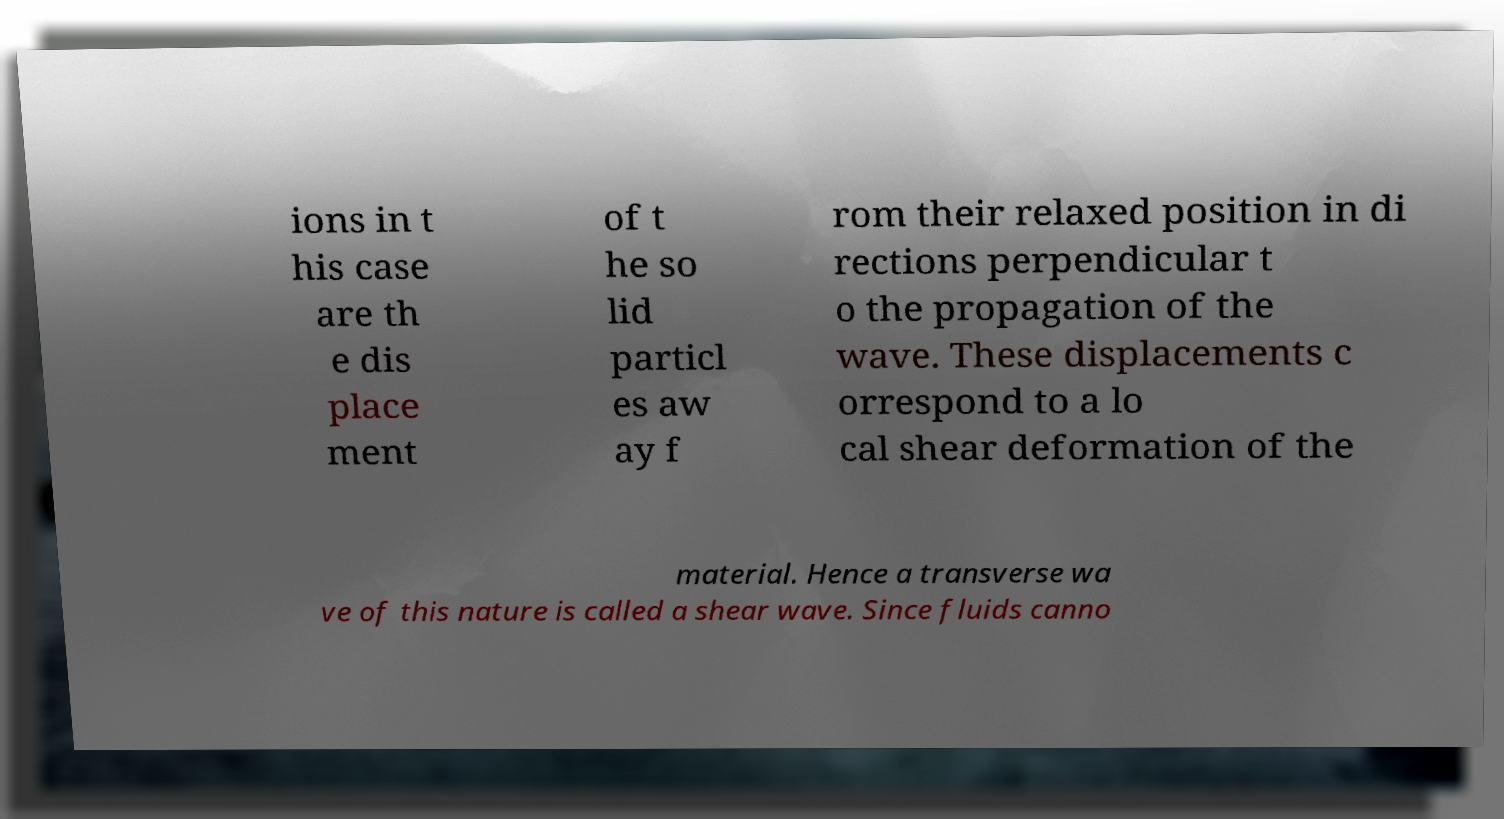Please read and relay the text visible in this image. What does it say? ions in t his case are th e dis place ment of t he so lid particl es aw ay f rom their relaxed position in di rections perpendicular t o the propagation of the wave. These displacements c orrespond to a lo cal shear deformation of the material. Hence a transverse wa ve of this nature is called a shear wave. Since fluids canno 